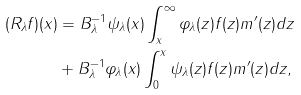<formula> <loc_0><loc_0><loc_500><loc_500>( R _ { \lambda } f ) ( x ) & = B ^ { - 1 } _ { \lambda } \psi _ { \lambda } ( x ) \int _ { x } ^ { \infty } \varphi _ { \lambda } ( z ) f ( z ) m ^ { \prime } ( z ) d z \\ & + B ^ { - 1 } _ { \lambda } \varphi _ { \lambda } ( x ) \int _ { 0 } ^ { x } \psi _ { \lambda } ( z ) f ( z ) m ^ { \prime } ( z ) d z ,</formula> 